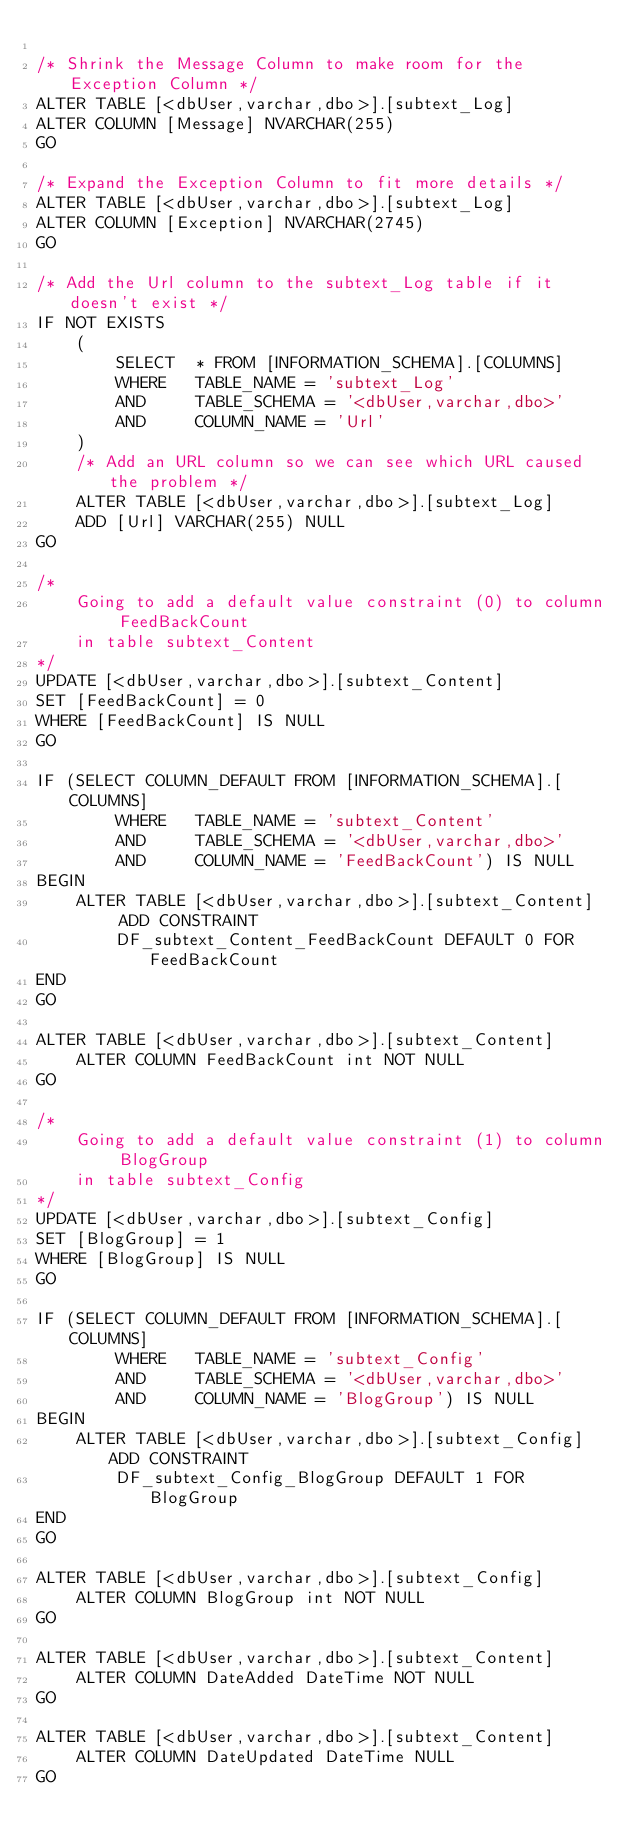Convert code to text. <code><loc_0><loc_0><loc_500><loc_500><_SQL_>
/* Shrink the Message Column to make room for the Exception Column */
ALTER TABLE [<dbUser,varchar,dbo>].[subtext_Log] 
ALTER COLUMN [Message] NVARCHAR(255)
GO

/* Expand the Exception Column to fit more details */
ALTER TABLE [<dbUser,varchar,dbo>].[subtext_Log] 
ALTER COLUMN [Exception] NVARCHAR(2745)
GO

/* Add the Url column to the subtext_Log table if it doesn't exist */
IF NOT EXISTS 
	(
		SELECT	* FROM [INFORMATION_SCHEMA].[COLUMNS] 
		WHERE	TABLE_NAME = 'subtext_Log' 
		AND		TABLE_SCHEMA = '<dbUser,varchar,dbo>'
		AND		COLUMN_NAME = 'Url'
	)
	/* Add an URL column so we can see which URL caused the problem */
	ALTER TABLE [<dbUser,varchar,dbo>].[subtext_Log] 
	ADD [Url] VARCHAR(255) NULL
GO

/*
	Going to add a default value constraint (0) to column FeedBackCount 
	in table subtext_Content 
*/
UPDATE [<dbUser,varchar,dbo>].[subtext_Content] 
SET [FeedBackCount] = 0
WHERE [FeedBackCount] IS NULL
GO

IF (SELECT COLUMN_DEFAULT FROM [INFORMATION_SCHEMA].[COLUMNS] 
		WHERE	TABLE_NAME = 'subtext_Content'
		AND		TABLE_SCHEMA = '<dbUser,varchar,dbo>'
		AND		COLUMN_NAME = 'FeedBackCount') IS NULL
BEGIN
	ALTER TABLE [<dbUser,varchar,dbo>].[subtext_Content]  ADD CONSTRAINT
		DF_subtext_Content_FeedBackCount DEFAULT 0 FOR FeedBackCount
END
GO

ALTER TABLE [<dbUser,varchar,dbo>].[subtext_Content]  
	ALTER COLUMN FeedBackCount int NOT NULL
GO

/*
	Going to add a default value constraint (1) to column BlogGroup 
	in table subtext_Config 
*/
UPDATE [<dbUser,varchar,dbo>].[subtext_Config] 
SET [BlogGroup] = 1
WHERE [BlogGroup] IS NULL
GO

IF (SELECT COLUMN_DEFAULT FROM [INFORMATION_SCHEMA].[COLUMNS] 
		WHERE	TABLE_NAME = 'subtext_Config'
		AND		TABLE_SCHEMA = '<dbUser,varchar,dbo>'
		AND		COLUMN_NAME = 'BlogGroup') IS NULL
BEGIN
	ALTER TABLE [<dbUser,varchar,dbo>].[subtext_Config]  ADD CONSTRAINT
		DF_subtext_Config_BlogGroup DEFAULT 1 FOR BlogGroup
END
GO

ALTER TABLE [<dbUser,varchar,dbo>].[subtext_Config]
	ALTER COLUMN BlogGroup int NOT NULL
GO

ALTER TABLE [<dbUser,varchar,dbo>].[subtext_Content]  
	ALTER COLUMN DateAdded DateTime NOT NULL
GO

ALTER TABLE [<dbUser,varchar,dbo>].[subtext_Content]
	ALTER COLUMN DateUpdated DateTime NULL
GO
</code> 